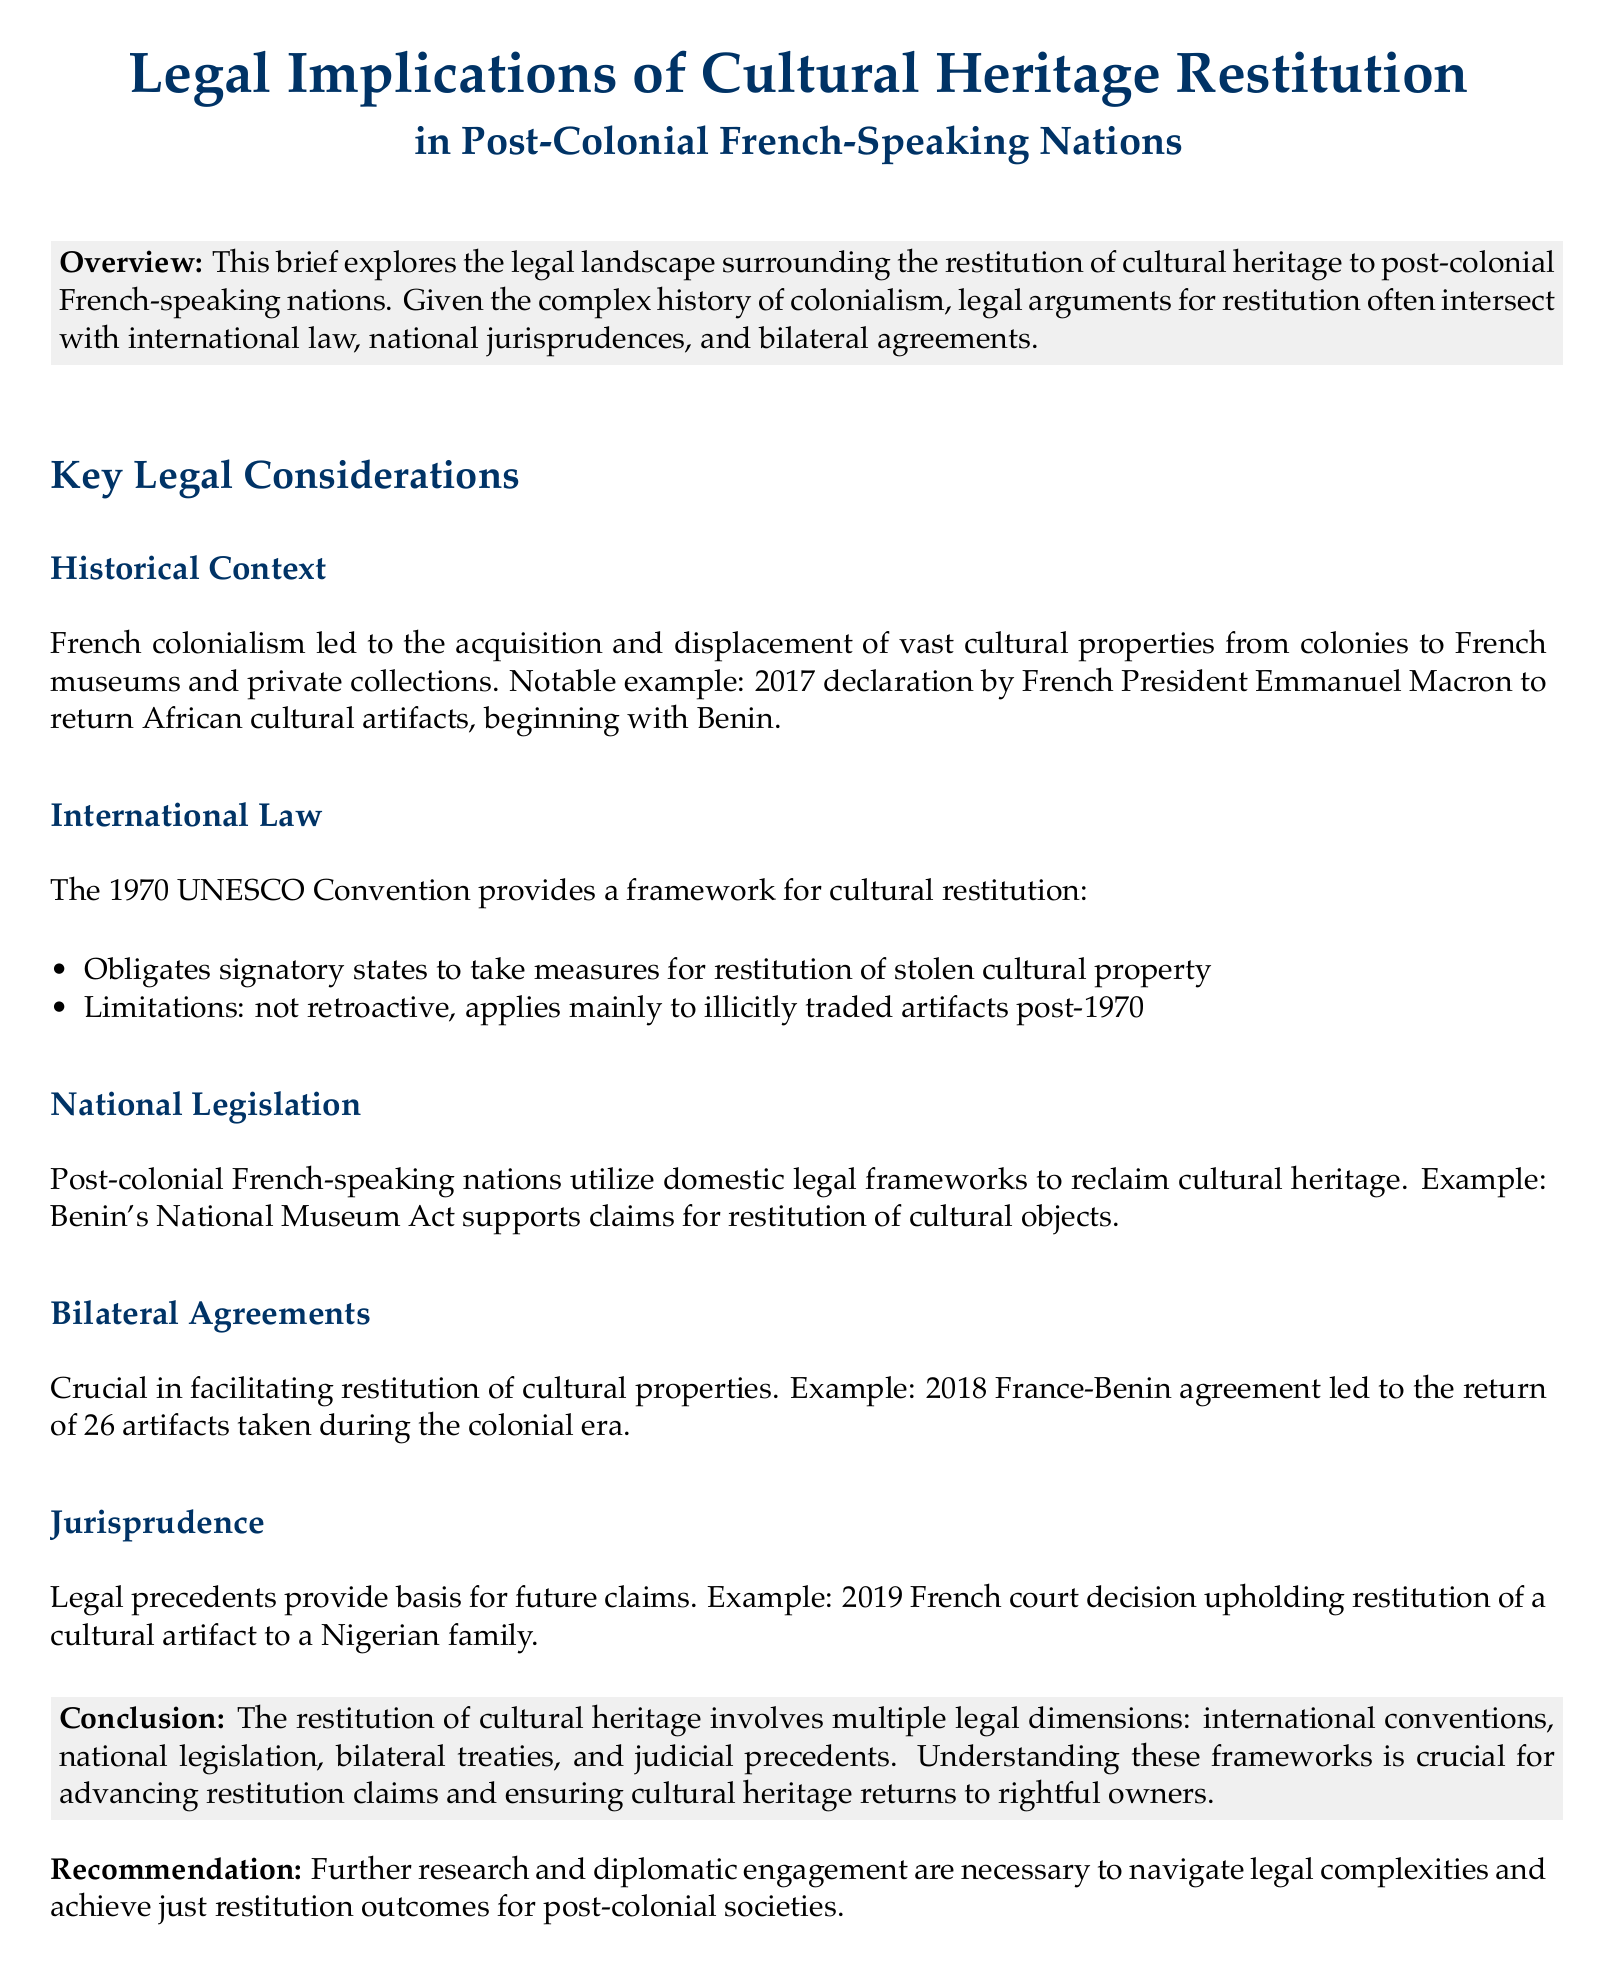What is the title of the brief? The title provides insight into the document's focus on legal implications of cultural heritage restitution.
Answer: Legal Implications of Cultural Heritage Restitution in Post-Colonial French-Speaking Nations Who made the declaration to return African cultural artifacts in 2017? The brief mentions a declaration made by a notable figure related to cultural restitution efforts.
Answer: Emmanuel Macron What international convention is referenced in the document? The document specifies a significant international framework related to cultural restitution.
Answer: 1970 UNESCO Convention How many artifacts were returned to Benin in the 2018 agreement? This detail highlights a specific restitution action taken between France and Benin.
Answer: 26 artifacts What supports claims for restitution of cultural objects in Benin? This refers to the legal framework utilized by Benin to reclaim cultural heritage.
Answer: Benin's National Museum Act What type of agreements are crucial in facilitating restitution? This question addresses the types of legal documents necessary for the process of cultural heritage restitution.
Answer: Bilateral Agreements In which year was a French court decision made regarding restitution to a Nigerian family? This highlights a significant legal decision that impacts future restitution claims.
Answer: 2019 What is the brief's recommendation for achieving restitution outcomes? The document concludes with a call to action that advocates for a specific approach to address restitution issues.
Answer: Further research and diplomatic engagement 